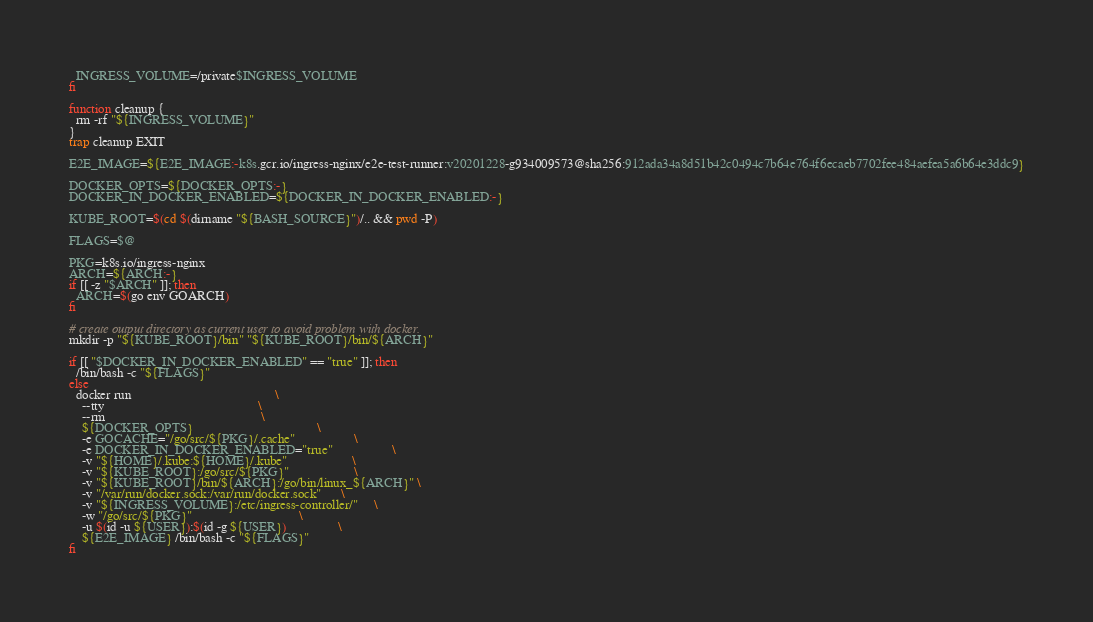Convert code to text. <code><loc_0><loc_0><loc_500><loc_500><_Bash_>  INGRESS_VOLUME=/private$INGRESS_VOLUME
fi

function cleanup {
  rm -rf "${INGRESS_VOLUME}"
}
trap cleanup EXIT

E2E_IMAGE=${E2E_IMAGE:-k8s.gcr.io/ingress-nginx/e2e-test-runner:v20201228-g934009573@sha256:912ada34a8d51b42c0494c7b64e764f6ecaeb7702fee484aefea5a6b64e3ddc9}

DOCKER_OPTS=${DOCKER_OPTS:-}
DOCKER_IN_DOCKER_ENABLED=${DOCKER_IN_DOCKER_ENABLED:-}

KUBE_ROOT=$(cd $(dirname "${BASH_SOURCE}")/.. && pwd -P)

FLAGS=$@

PKG=k8s.io/ingress-nginx
ARCH=${ARCH:-}
if [[ -z "$ARCH" ]]; then
  ARCH=$(go env GOARCH)
fi

# create output directory as current user to avoid problem with docker.
mkdir -p "${KUBE_ROOT}/bin" "${KUBE_ROOT}/bin/${ARCH}"

if [[ "$DOCKER_IN_DOCKER_ENABLED" == "true" ]]; then
  /bin/bash -c "${FLAGS}"
else
  docker run                                            \
    --tty                                               \
    --rm                                                \
    ${DOCKER_OPTS}                                      \
    -e GOCACHE="/go/src/${PKG}/.cache"                  \
    -e DOCKER_IN_DOCKER_ENABLED="true"                  \
    -v "${HOME}/.kube:${HOME}/.kube"                    \
    -v "${KUBE_ROOT}:/go/src/${PKG}"                    \
    -v "${KUBE_ROOT}/bin/${ARCH}:/go/bin/linux_${ARCH}" \
    -v "/var/run/docker.sock:/var/run/docker.sock"      \
    -v "${INGRESS_VOLUME}:/etc/ingress-controller/"     \
    -w "/go/src/${PKG}"                                 \
    -u $(id -u ${USER}):$(id -g ${USER})                \
    ${E2E_IMAGE} /bin/bash -c "${FLAGS}"
fi
</code> 